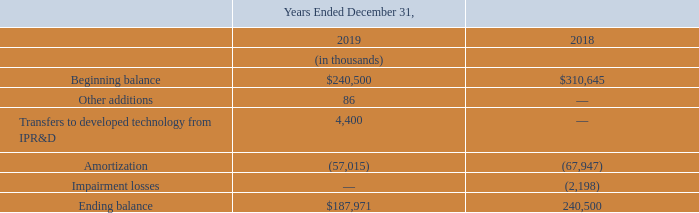The following table sets forth activity during the years ended December 31, 2019 and 2018 related to finite-lived intangible assets:
The Company regularly reviews the carrying amounts of its long-lived assets subject to depreciation and amortization, as well as the related useful lives, to determine whether indicators of impairment may exist which warrant adjustments to carrying values or estimated useful lives. An impairment loss is recognized when the sum of the expected future undiscounted net cash flows is less than the carrying amount of the asset.
Should impairment exist, the impairment loss is measured based on the excess of the carrying amount of the asset over the asset’s fair value. During the years ended December 31, 2019 and 2017, no impairment losses related to finite-lived intangible assets were recognized. Impairment loss related to finite-lived intangible assets for the year ended December 31, 2018 was $2.2 million and related to acquired developed technology.
When is the impairment loss recognized? When the sum of the expected future undiscounted net cash flows is less than the carrying amount of the asset. What was the Impairment loss related to finite-lived intangible assets in 2018? $2.2 million. What were the other additions in 2019 and 2018 respectively?
Answer scale should be: thousand. 86, 0. What was the change in the Beginning balance from 2018 to 2019?
Answer scale should be: thousand. 240,500 - 310,645
Answer: -70145. What is the average other additions for 2018 and 2019?
Answer scale should be: thousand. (86 + 0) / 2
Answer: 43. In which year was Transfers to developed technology from IPR&D greater than 4,000 thousands? Locate and analyze transfers to developed technology from ipr&d in row 6
answer: 2019. 